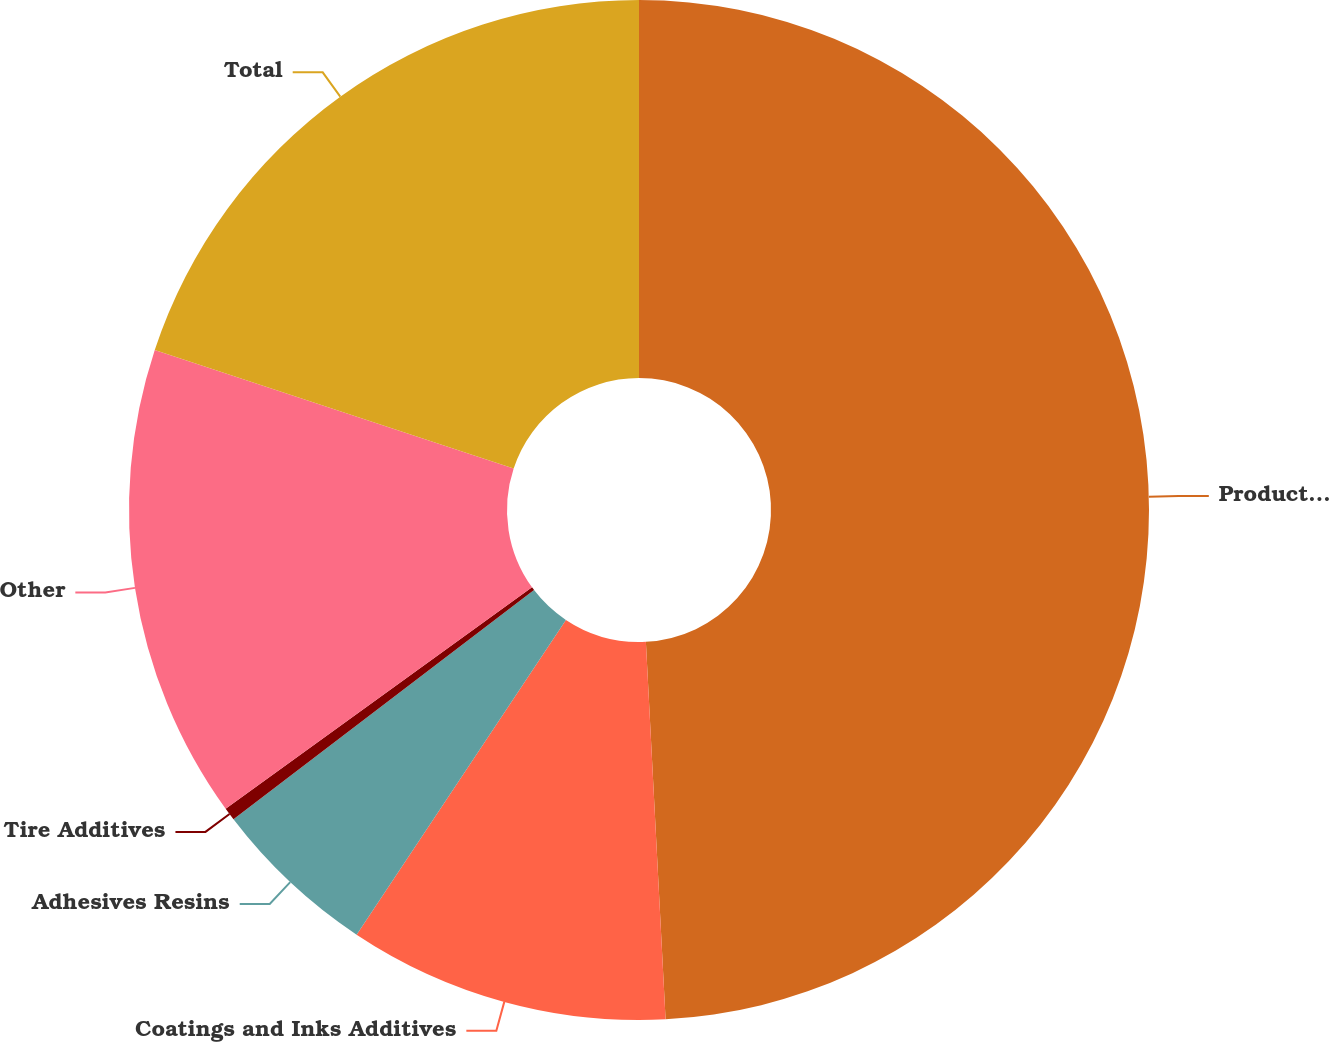<chart> <loc_0><loc_0><loc_500><loc_500><pie_chart><fcel>Product Lines<fcel>Coatings and Inks Additives<fcel>Adhesives Resins<fcel>Tire Additives<fcel>Other<fcel>Total<nl><fcel>49.17%<fcel>10.17%<fcel>5.29%<fcel>0.41%<fcel>15.04%<fcel>19.92%<nl></chart> 